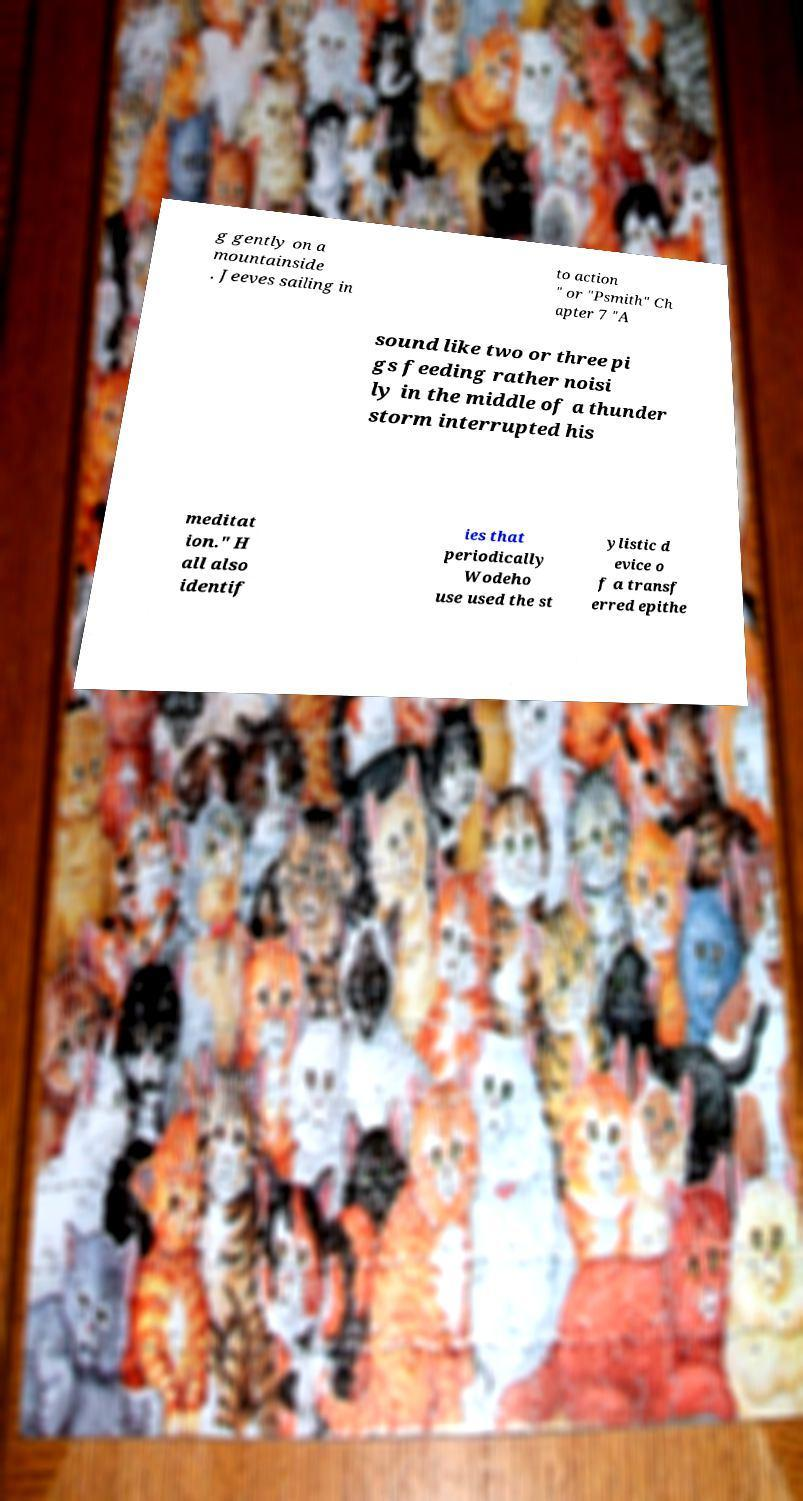Could you extract and type out the text from this image? g gently on a mountainside . Jeeves sailing in to action " or "Psmith" Ch apter 7 "A sound like two or three pi gs feeding rather noisi ly in the middle of a thunder storm interrupted his meditat ion." H all also identif ies that periodically Wodeho use used the st ylistic d evice o f a transf erred epithe 